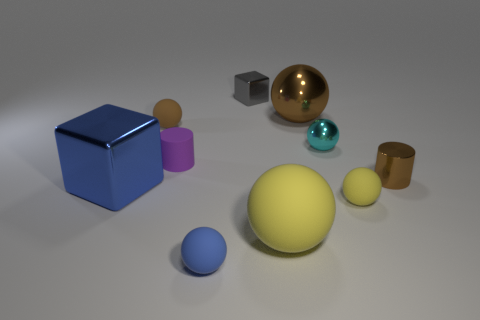Subtract all blue spheres. How many spheres are left? 5 Subtract all brown balls. How many brown cylinders are left? 1 Subtract all cyan balls. How many balls are left? 5 Subtract all cylinders. How many objects are left? 8 Subtract 2 cylinders. How many cylinders are left? 0 Subtract all blue blocks. Subtract all yellow cylinders. How many blocks are left? 1 Subtract all large spheres. Subtract all brown things. How many objects are left? 5 Add 7 large brown balls. How many large brown balls are left? 8 Add 9 cyan shiny objects. How many cyan shiny objects exist? 10 Subtract 0 green cubes. How many objects are left? 10 